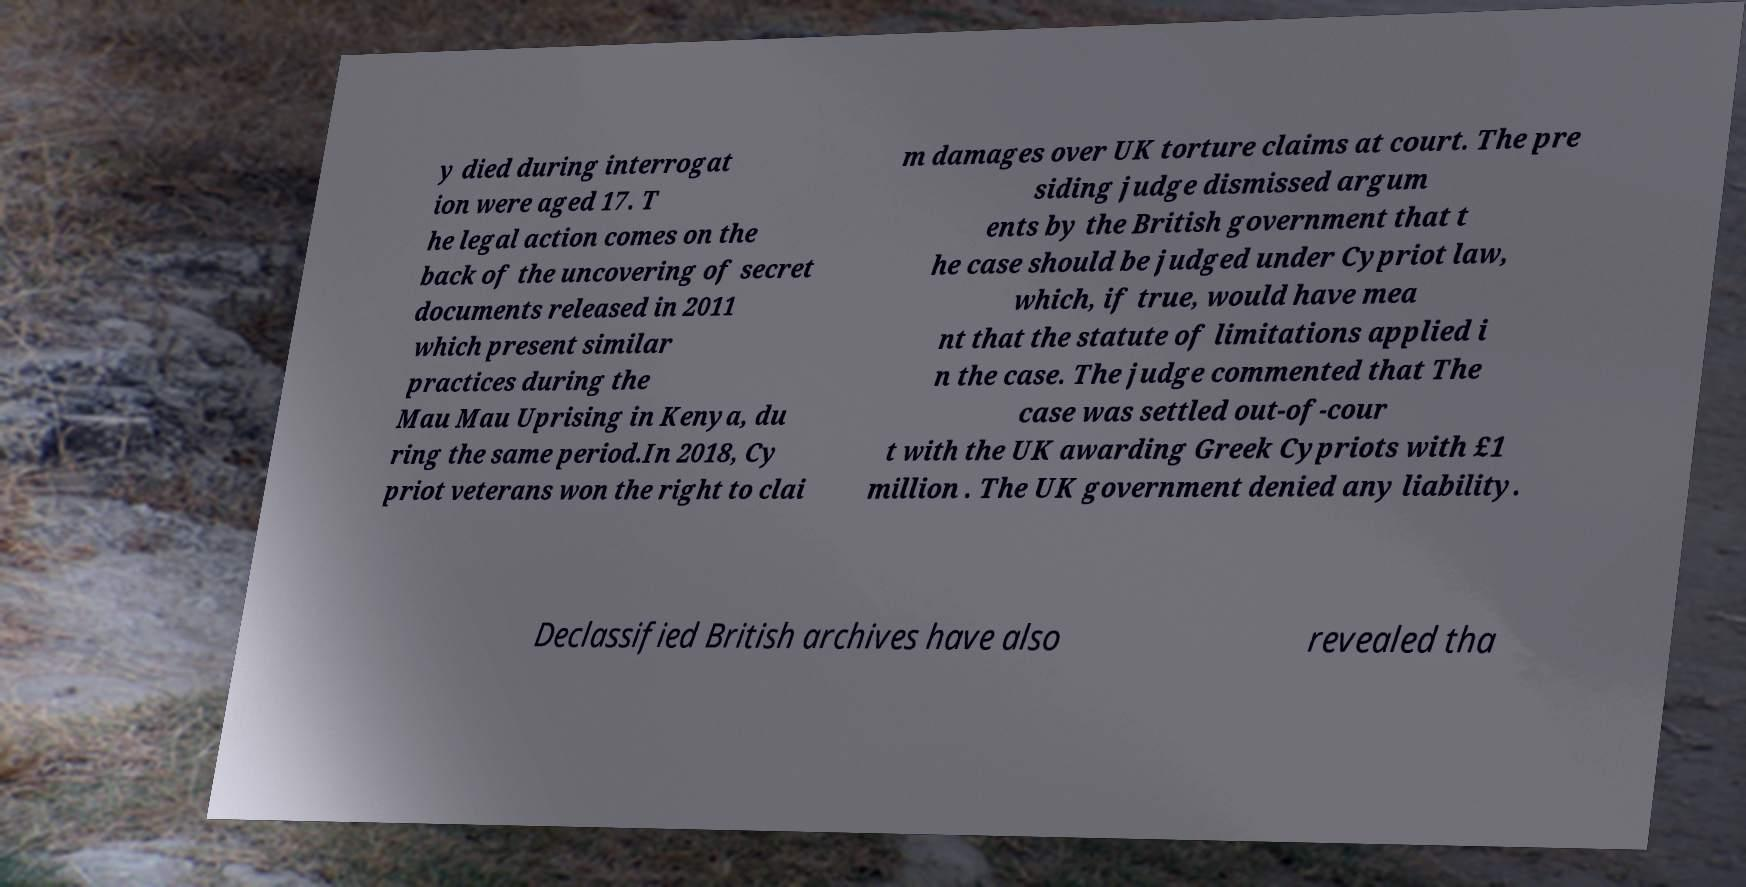Please read and relay the text visible in this image. What does it say? y died during interrogat ion were aged 17. T he legal action comes on the back of the uncovering of secret documents released in 2011 which present similar practices during the Mau Mau Uprising in Kenya, du ring the same period.In 2018, Cy priot veterans won the right to clai m damages over UK torture claims at court. The pre siding judge dismissed argum ents by the British government that t he case should be judged under Cypriot law, which, if true, would have mea nt that the statute of limitations applied i n the case. The judge commented that The case was settled out-of-cour t with the UK awarding Greek Cypriots with £1 million . The UK government denied any liability. Declassified British archives have also revealed tha 